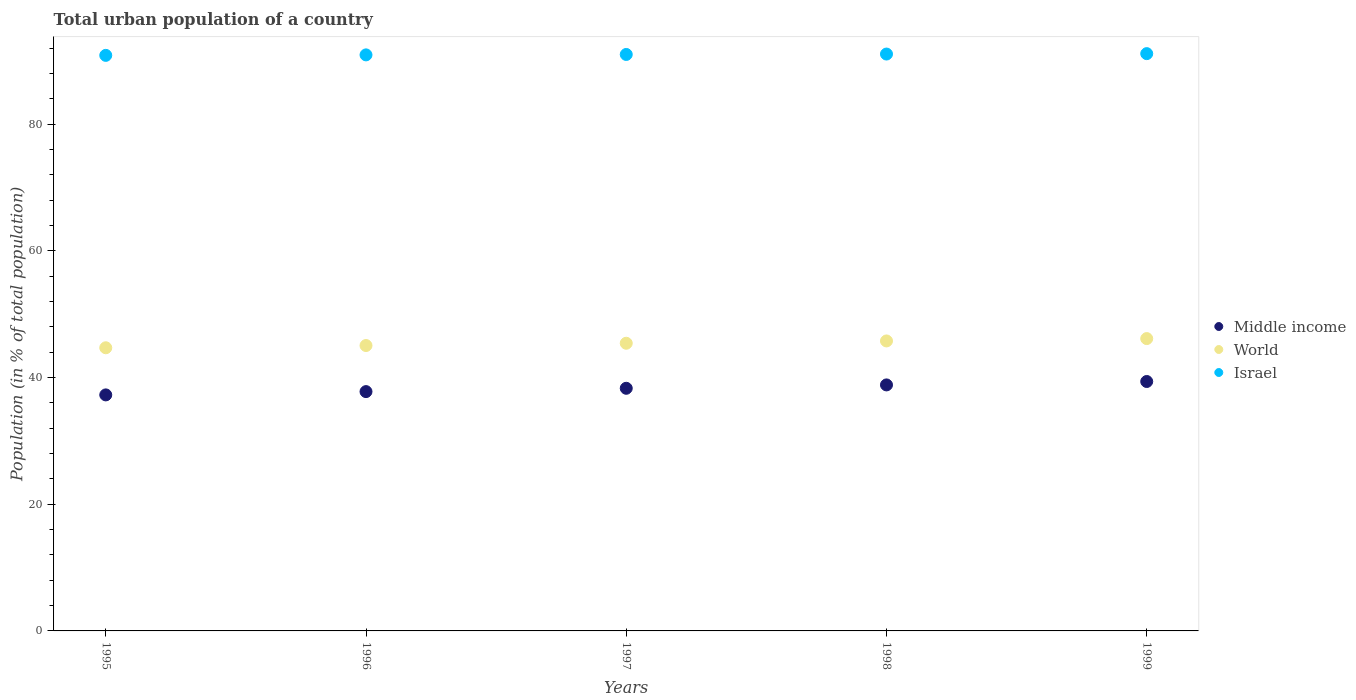How many different coloured dotlines are there?
Keep it short and to the point. 3. What is the urban population in World in 1999?
Your answer should be very brief. 46.15. Across all years, what is the maximum urban population in Israel?
Provide a short and direct response. 91.14. Across all years, what is the minimum urban population in Middle income?
Provide a succinct answer. 37.26. What is the total urban population in World in the graph?
Your answer should be compact. 227.11. What is the difference between the urban population in Israel in 1996 and that in 1999?
Your answer should be compact. -0.2. What is the difference between the urban population in World in 1999 and the urban population in Middle income in 1996?
Offer a very short reply. 8.37. What is the average urban population in World per year?
Your answer should be compact. 45.42. In the year 1995, what is the difference between the urban population in Middle income and urban population in World?
Your answer should be very brief. -7.44. What is the ratio of the urban population in Middle income in 1995 to that in 1999?
Provide a short and direct response. 0.95. Is the difference between the urban population in Middle income in 1996 and 1997 greater than the difference between the urban population in World in 1996 and 1997?
Your answer should be compact. No. What is the difference between the highest and the second highest urban population in World?
Offer a terse response. 0.37. What is the difference between the highest and the lowest urban population in Middle income?
Offer a very short reply. 2.11. Is it the case that in every year, the sum of the urban population in Israel and urban population in World  is greater than the urban population in Middle income?
Offer a terse response. Yes. Does the urban population in Middle income monotonically increase over the years?
Your answer should be compact. Yes. Is the urban population in Israel strictly greater than the urban population in Middle income over the years?
Your answer should be very brief. Yes. How many years are there in the graph?
Offer a very short reply. 5. Are the values on the major ticks of Y-axis written in scientific E-notation?
Provide a short and direct response. No. Where does the legend appear in the graph?
Give a very brief answer. Center right. How are the legend labels stacked?
Keep it short and to the point. Vertical. What is the title of the graph?
Keep it short and to the point. Total urban population of a country. What is the label or title of the Y-axis?
Keep it short and to the point. Population (in % of total population). What is the Population (in % of total population) in Middle income in 1995?
Make the answer very short. 37.26. What is the Population (in % of total population) of World in 1995?
Give a very brief answer. 44.7. What is the Population (in % of total population) in Israel in 1995?
Provide a short and direct response. 90.87. What is the Population (in % of total population) of Middle income in 1996?
Provide a short and direct response. 37.78. What is the Population (in % of total population) in World in 1996?
Provide a succinct answer. 45.06. What is the Population (in % of total population) of Israel in 1996?
Keep it short and to the point. 90.94. What is the Population (in % of total population) of Middle income in 1997?
Make the answer very short. 38.31. What is the Population (in % of total population) in World in 1997?
Give a very brief answer. 45.42. What is the Population (in % of total population) of Israel in 1997?
Offer a very short reply. 91.01. What is the Population (in % of total population) in Middle income in 1998?
Give a very brief answer. 38.84. What is the Population (in % of total population) of World in 1998?
Keep it short and to the point. 45.78. What is the Population (in % of total population) in Israel in 1998?
Your response must be concise. 91.07. What is the Population (in % of total population) of Middle income in 1999?
Your answer should be compact. 39.38. What is the Population (in % of total population) of World in 1999?
Keep it short and to the point. 46.15. What is the Population (in % of total population) of Israel in 1999?
Your answer should be very brief. 91.14. Across all years, what is the maximum Population (in % of total population) of Middle income?
Your answer should be compact. 39.38. Across all years, what is the maximum Population (in % of total population) of World?
Provide a short and direct response. 46.15. Across all years, what is the maximum Population (in % of total population) of Israel?
Keep it short and to the point. 91.14. Across all years, what is the minimum Population (in % of total population) in Middle income?
Offer a very short reply. 37.26. Across all years, what is the minimum Population (in % of total population) in World?
Give a very brief answer. 44.7. Across all years, what is the minimum Population (in % of total population) in Israel?
Make the answer very short. 90.87. What is the total Population (in % of total population) in Middle income in the graph?
Provide a short and direct response. 191.57. What is the total Population (in % of total population) of World in the graph?
Provide a short and direct response. 227.11. What is the total Population (in % of total population) of Israel in the graph?
Make the answer very short. 455.03. What is the difference between the Population (in % of total population) in Middle income in 1995 and that in 1996?
Offer a terse response. -0.52. What is the difference between the Population (in % of total population) in World in 1995 and that in 1996?
Make the answer very short. -0.35. What is the difference between the Population (in % of total population) in Israel in 1995 and that in 1996?
Your response must be concise. -0.08. What is the difference between the Population (in % of total population) in Middle income in 1995 and that in 1997?
Offer a terse response. -1.04. What is the difference between the Population (in % of total population) of World in 1995 and that in 1997?
Your answer should be very brief. -0.71. What is the difference between the Population (in % of total population) in Israel in 1995 and that in 1997?
Ensure brevity in your answer.  -0.14. What is the difference between the Population (in % of total population) in Middle income in 1995 and that in 1998?
Provide a succinct answer. -1.58. What is the difference between the Population (in % of total population) of World in 1995 and that in 1998?
Your answer should be very brief. -1.08. What is the difference between the Population (in % of total population) in Israel in 1995 and that in 1998?
Offer a very short reply. -0.21. What is the difference between the Population (in % of total population) of Middle income in 1995 and that in 1999?
Provide a short and direct response. -2.11. What is the difference between the Population (in % of total population) of World in 1995 and that in 1999?
Give a very brief answer. -1.45. What is the difference between the Population (in % of total population) in Israel in 1995 and that in 1999?
Offer a terse response. -0.27. What is the difference between the Population (in % of total population) of Middle income in 1996 and that in 1997?
Your response must be concise. -0.52. What is the difference between the Population (in % of total population) in World in 1996 and that in 1997?
Keep it short and to the point. -0.36. What is the difference between the Population (in % of total population) of Israel in 1996 and that in 1997?
Provide a short and direct response. -0.07. What is the difference between the Population (in % of total population) of Middle income in 1996 and that in 1998?
Your answer should be compact. -1.06. What is the difference between the Population (in % of total population) in World in 1996 and that in 1998?
Ensure brevity in your answer.  -0.72. What is the difference between the Population (in % of total population) in Israel in 1996 and that in 1998?
Give a very brief answer. -0.13. What is the difference between the Population (in % of total population) of Middle income in 1996 and that in 1999?
Offer a terse response. -1.6. What is the difference between the Population (in % of total population) in World in 1996 and that in 1999?
Give a very brief answer. -1.09. What is the difference between the Population (in % of total population) of Israel in 1996 and that in 1999?
Offer a very short reply. -0.2. What is the difference between the Population (in % of total population) in Middle income in 1997 and that in 1998?
Ensure brevity in your answer.  -0.53. What is the difference between the Population (in % of total population) of World in 1997 and that in 1998?
Make the answer very short. -0.36. What is the difference between the Population (in % of total population) in Israel in 1997 and that in 1998?
Keep it short and to the point. -0.07. What is the difference between the Population (in % of total population) of Middle income in 1997 and that in 1999?
Ensure brevity in your answer.  -1.07. What is the difference between the Population (in % of total population) of World in 1997 and that in 1999?
Offer a terse response. -0.74. What is the difference between the Population (in % of total population) in Israel in 1997 and that in 1999?
Provide a short and direct response. -0.13. What is the difference between the Population (in % of total population) in Middle income in 1998 and that in 1999?
Your response must be concise. -0.54. What is the difference between the Population (in % of total population) in World in 1998 and that in 1999?
Give a very brief answer. -0.37. What is the difference between the Population (in % of total population) in Israel in 1998 and that in 1999?
Your response must be concise. -0.07. What is the difference between the Population (in % of total population) of Middle income in 1995 and the Population (in % of total population) of World in 1996?
Offer a very short reply. -7.79. What is the difference between the Population (in % of total population) in Middle income in 1995 and the Population (in % of total population) in Israel in 1996?
Your answer should be compact. -53.68. What is the difference between the Population (in % of total population) in World in 1995 and the Population (in % of total population) in Israel in 1996?
Ensure brevity in your answer.  -46.24. What is the difference between the Population (in % of total population) of Middle income in 1995 and the Population (in % of total population) of World in 1997?
Your answer should be compact. -8.15. What is the difference between the Population (in % of total population) of Middle income in 1995 and the Population (in % of total population) of Israel in 1997?
Give a very brief answer. -53.75. What is the difference between the Population (in % of total population) in World in 1995 and the Population (in % of total population) in Israel in 1997?
Give a very brief answer. -46.31. What is the difference between the Population (in % of total population) in Middle income in 1995 and the Population (in % of total population) in World in 1998?
Provide a short and direct response. -8.52. What is the difference between the Population (in % of total population) in Middle income in 1995 and the Population (in % of total population) in Israel in 1998?
Your response must be concise. -53.81. What is the difference between the Population (in % of total population) of World in 1995 and the Population (in % of total population) of Israel in 1998?
Ensure brevity in your answer.  -46.37. What is the difference between the Population (in % of total population) of Middle income in 1995 and the Population (in % of total population) of World in 1999?
Keep it short and to the point. -8.89. What is the difference between the Population (in % of total population) of Middle income in 1995 and the Population (in % of total population) of Israel in 1999?
Your response must be concise. -53.88. What is the difference between the Population (in % of total population) of World in 1995 and the Population (in % of total population) of Israel in 1999?
Keep it short and to the point. -46.44. What is the difference between the Population (in % of total population) in Middle income in 1996 and the Population (in % of total population) in World in 1997?
Your answer should be very brief. -7.63. What is the difference between the Population (in % of total population) of Middle income in 1996 and the Population (in % of total population) of Israel in 1997?
Provide a succinct answer. -53.23. What is the difference between the Population (in % of total population) in World in 1996 and the Population (in % of total population) in Israel in 1997?
Give a very brief answer. -45.95. What is the difference between the Population (in % of total population) of Middle income in 1996 and the Population (in % of total population) of World in 1998?
Make the answer very short. -8. What is the difference between the Population (in % of total population) of Middle income in 1996 and the Population (in % of total population) of Israel in 1998?
Your answer should be very brief. -53.29. What is the difference between the Population (in % of total population) of World in 1996 and the Population (in % of total population) of Israel in 1998?
Provide a succinct answer. -46.02. What is the difference between the Population (in % of total population) of Middle income in 1996 and the Population (in % of total population) of World in 1999?
Make the answer very short. -8.37. What is the difference between the Population (in % of total population) in Middle income in 1996 and the Population (in % of total population) in Israel in 1999?
Provide a succinct answer. -53.36. What is the difference between the Population (in % of total population) of World in 1996 and the Population (in % of total population) of Israel in 1999?
Ensure brevity in your answer.  -46.08. What is the difference between the Population (in % of total population) in Middle income in 1997 and the Population (in % of total population) in World in 1998?
Your response must be concise. -7.47. What is the difference between the Population (in % of total population) of Middle income in 1997 and the Population (in % of total population) of Israel in 1998?
Keep it short and to the point. -52.77. What is the difference between the Population (in % of total population) of World in 1997 and the Population (in % of total population) of Israel in 1998?
Your response must be concise. -45.66. What is the difference between the Population (in % of total population) of Middle income in 1997 and the Population (in % of total population) of World in 1999?
Make the answer very short. -7.85. What is the difference between the Population (in % of total population) of Middle income in 1997 and the Population (in % of total population) of Israel in 1999?
Provide a short and direct response. -52.83. What is the difference between the Population (in % of total population) of World in 1997 and the Population (in % of total population) of Israel in 1999?
Your answer should be very brief. -45.72. What is the difference between the Population (in % of total population) in Middle income in 1998 and the Population (in % of total population) in World in 1999?
Offer a terse response. -7.31. What is the difference between the Population (in % of total population) of Middle income in 1998 and the Population (in % of total population) of Israel in 1999?
Keep it short and to the point. -52.3. What is the difference between the Population (in % of total population) in World in 1998 and the Population (in % of total population) in Israel in 1999?
Make the answer very short. -45.36. What is the average Population (in % of total population) of Middle income per year?
Offer a terse response. 38.31. What is the average Population (in % of total population) in World per year?
Offer a terse response. 45.42. What is the average Population (in % of total population) in Israel per year?
Make the answer very short. 91.01. In the year 1995, what is the difference between the Population (in % of total population) in Middle income and Population (in % of total population) in World?
Ensure brevity in your answer.  -7.44. In the year 1995, what is the difference between the Population (in % of total population) of Middle income and Population (in % of total population) of Israel?
Provide a succinct answer. -53.6. In the year 1995, what is the difference between the Population (in % of total population) in World and Population (in % of total population) in Israel?
Your answer should be compact. -46.16. In the year 1996, what is the difference between the Population (in % of total population) of Middle income and Population (in % of total population) of World?
Keep it short and to the point. -7.28. In the year 1996, what is the difference between the Population (in % of total population) of Middle income and Population (in % of total population) of Israel?
Provide a succinct answer. -53.16. In the year 1996, what is the difference between the Population (in % of total population) of World and Population (in % of total population) of Israel?
Your response must be concise. -45.89. In the year 1997, what is the difference between the Population (in % of total population) in Middle income and Population (in % of total population) in World?
Your response must be concise. -7.11. In the year 1997, what is the difference between the Population (in % of total population) in Middle income and Population (in % of total population) in Israel?
Keep it short and to the point. -52.7. In the year 1997, what is the difference between the Population (in % of total population) in World and Population (in % of total population) in Israel?
Make the answer very short. -45.59. In the year 1998, what is the difference between the Population (in % of total population) in Middle income and Population (in % of total population) in World?
Provide a short and direct response. -6.94. In the year 1998, what is the difference between the Population (in % of total population) of Middle income and Population (in % of total population) of Israel?
Your answer should be very brief. -52.23. In the year 1998, what is the difference between the Population (in % of total population) of World and Population (in % of total population) of Israel?
Offer a terse response. -45.29. In the year 1999, what is the difference between the Population (in % of total population) of Middle income and Population (in % of total population) of World?
Ensure brevity in your answer.  -6.78. In the year 1999, what is the difference between the Population (in % of total population) of Middle income and Population (in % of total population) of Israel?
Your response must be concise. -51.76. In the year 1999, what is the difference between the Population (in % of total population) in World and Population (in % of total population) in Israel?
Your answer should be compact. -44.99. What is the ratio of the Population (in % of total population) of Middle income in 1995 to that in 1996?
Provide a succinct answer. 0.99. What is the ratio of the Population (in % of total population) of World in 1995 to that in 1996?
Keep it short and to the point. 0.99. What is the ratio of the Population (in % of total population) of Middle income in 1995 to that in 1997?
Keep it short and to the point. 0.97. What is the ratio of the Population (in % of total population) of World in 1995 to that in 1997?
Ensure brevity in your answer.  0.98. What is the ratio of the Population (in % of total population) in Israel in 1995 to that in 1997?
Keep it short and to the point. 1. What is the ratio of the Population (in % of total population) in Middle income in 1995 to that in 1998?
Make the answer very short. 0.96. What is the ratio of the Population (in % of total population) of World in 1995 to that in 1998?
Ensure brevity in your answer.  0.98. What is the ratio of the Population (in % of total population) in Israel in 1995 to that in 1998?
Provide a succinct answer. 1. What is the ratio of the Population (in % of total population) of Middle income in 1995 to that in 1999?
Give a very brief answer. 0.95. What is the ratio of the Population (in % of total population) in World in 1995 to that in 1999?
Offer a terse response. 0.97. What is the ratio of the Population (in % of total population) in Middle income in 1996 to that in 1997?
Keep it short and to the point. 0.99. What is the ratio of the Population (in % of total population) of Israel in 1996 to that in 1997?
Offer a terse response. 1. What is the ratio of the Population (in % of total population) in Middle income in 1996 to that in 1998?
Make the answer very short. 0.97. What is the ratio of the Population (in % of total population) of World in 1996 to that in 1998?
Make the answer very short. 0.98. What is the ratio of the Population (in % of total population) in Israel in 1996 to that in 1998?
Ensure brevity in your answer.  1. What is the ratio of the Population (in % of total population) in Middle income in 1996 to that in 1999?
Make the answer very short. 0.96. What is the ratio of the Population (in % of total population) in World in 1996 to that in 1999?
Offer a very short reply. 0.98. What is the ratio of the Population (in % of total population) in Israel in 1996 to that in 1999?
Your answer should be compact. 1. What is the ratio of the Population (in % of total population) of Middle income in 1997 to that in 1998?
Your response must be concise. 0.99. What is the ratio of the Population (in % of total population) in World in 1997 to that in 1998?
Provide a short and direct response. 0.99. What is the ratio of the Population (in % of total population) of Middle income in 1997 to that in 1999?
Your response must be concise. 0.97. What is the ratio of the Population (in % of total population) of World in 1997 to that in 1999?
Your response must be concise. 0.98. What is the ratio of the Population (in % of total population) in Israel in 1997 to that in 1999?
Your answer should be very brief. 1. What is the ratio of the Population (in % of total population) in Middle income in 1998 to that in 1999?
Make the answer very short. 0.99. What is the ratio of the Population (in % of total population) in World in 1998 to that in 1999?
Your response must be concise. 0.99. What is the ratio of the Population (in % of total population) in Israel in 1998 to that in 1999?
Your response must be concise. 1. What is the difference between the highest and the second highest Population (in % of total population) of Middle income?
Give a very brief answer. 0.54. What is the difference between the highest and the second highest Population (in % of total population) in World?
Your answer should be compact. 0.37. What is the difference between the highest and the second highest Population (in % of total population) of Israel?
Your answer should be very brief. 0.07. What is the difference between the highest and the lowest Population (in % of total population) in Middle income?
Provide a short and direct response. 2.11. What is the difference between the highest and the lowest Population (in % of total population) of World?
Your answer should be very brief. 1.45. What is the difference between the highest and the lowest Population (in % of total population) of Israel?
Keep it short and to the point. 0.27. 